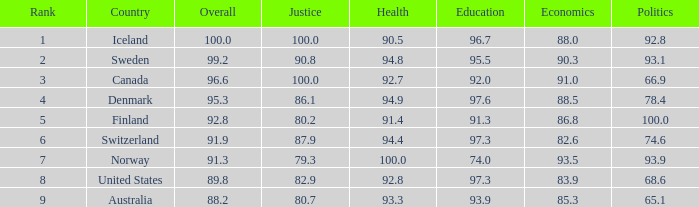0? 91.0. 